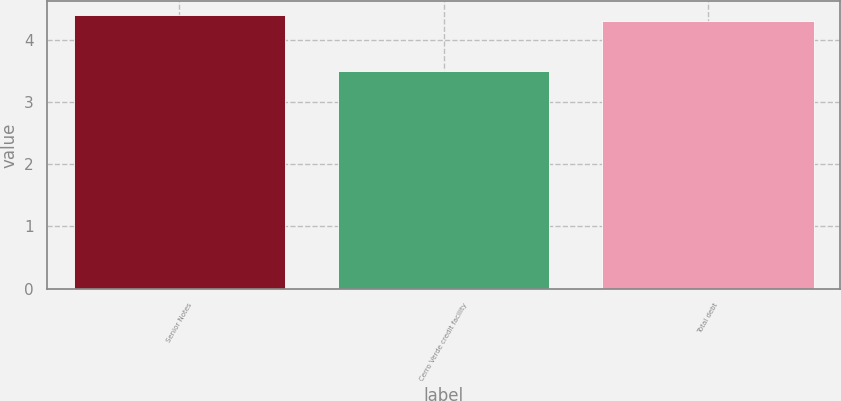Convert chart to OTSL. <chart><loc_0><loc_0><loc_500><loc_500><bar_chart><fcel>Senior Notes<fcel>Cerro Verde credit facility<fcel>Total debt<nl><fcel>4.4<fcel>3.5<fcel>4.3<nl></chart> 